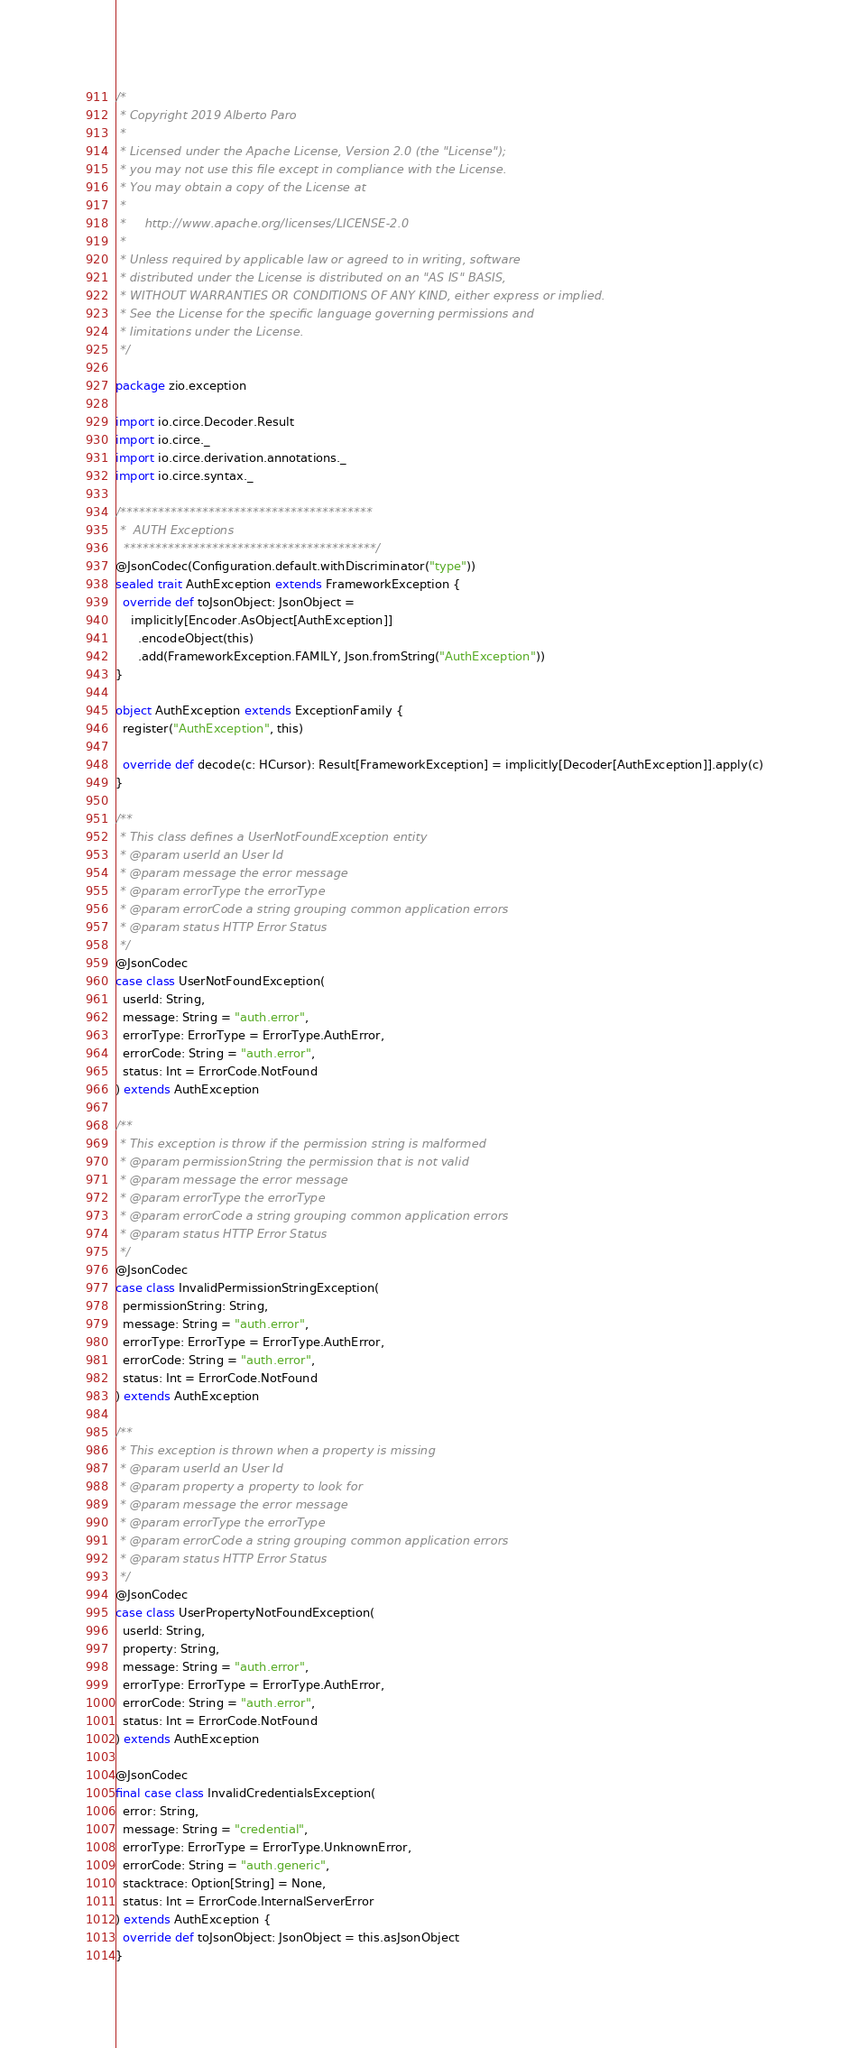<code> <loc_0><loc_0><loc_500><loc_500><_Scala_>/*
 * Copyright 2019 Alberto Paro
 *
 * Licensed under the Apache License, Version 2.0 (the "License");
 * you may not use this file except in compliance with the License.
 * You may obtain a copy of the License at
 *
 *     http://www.apache.org/licenses/LICENSE-2.0
 *
 * Unless required by applicable law or agreed to in writing, software
 * distributed under the License is distributed on an "AS IS" BASIS,
 * WITHOUT WARRANTIES OR CONDITIONS OF ANY KIND, either express or implied.
 * See the License for the specific language governing permissions and
 * limitations under the License.
 */

package zio.exception

import io.circe.Decoder.Result
import io.circe._
import io.circe.derivation.annotations._
import io.circe.syntax._

/****************************************
 *  AUTH Exceptions
  ****************************************/
@JsonCodec(Configuration.default.withDiscriminator("type"))
sealed trait AuthException extends FrameworkException {
  override def toJsonObject: JsonObject =
    implicitly[Encoder.AsObject[AuthException]]
      .encodeObject(this)
      .add(FrameworkException.FAMILY, Json.fromString("AuthException"))
}

object AuthException extends ExceptionFamily {
  register("AuthException", this)

  override def decode(c: HCursor): Result[FrameworkException] = implicitly[Decoder[AuthException]].apply(c)
}

/**
 * This class defines a UserNotFoundException entity
 * @param userId an User Id
 * @param message the error message
 * @param errorType the errorType
 * @param errorCode a string grouping common application errors
 * @param status HTTP Error Status
 */
@JsonCodec
case class UserNotFoundException(
  userId: String,
  message: String = "auth.error",
  errorType: ErrorType = ErrorType.AuthError,
  errorCode: String = "auth.error",
  status: Int = ErrorCode.NotFound
) extends AuthException

/**
 * This exception is throw if the permission string is malformed
 * @param permissionString the permission that is not valid
 * @param message the error message
 * @param errorType the errorType
 * @param errorCode a string grouping common application errors
 * @param status HTTP Error Status
 */
@JsonCodec
case class InvalidPermissionStringException(
  permissionString: String,
  message: String = "auth.error",
  errorType: ErrorType = ErrorType.AuthError,
  errorCode: String = "auth.error",
  status: Int = ErrorCode.NotFound
) extends AuthException

/**
 * This exception is thrown when a property is missing
 * @param userId an User Id
 * @param property a property to look for
 * @param message the error message
 * @param errorType the errorType
 * @param errorCode a string grouping common application errors
 * @param status HTTP Error Status
 */
@JsonCodec
case class UserPropertyNotFoundException(
  userId: String,
  property: String,
  message: String = "auth.error",
  errorType: ErrorType = ErrorType.AuthError,
  errorCode: String = "auth.error",
  status: Int = ErrorCode.NotFound
) extends AuthException

@JsonCodec
final case class InvalidCredentialsException(
  error: String,
  message: String = "credential",
  errorType: ErrorType = ErrorType.UnknownError,
  errorCode: String = "auth.generic",
  stacktrace: Option[String] = None,
  status: Int = ErrorCode.InternalServerError
) extends AuthException {
  override def toJsonObject: JsonObject = this.asJsonObject
}
</code> 